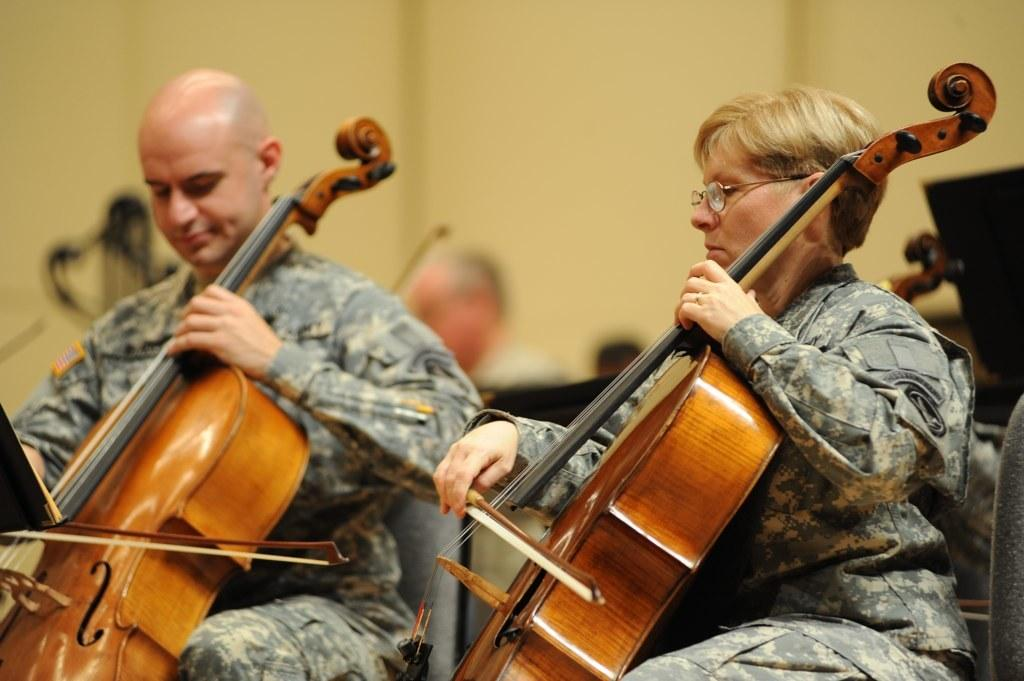What is the man in the image doing? The man is sitting and playing the violin. What is the woman in the image doing? The woman is also sitting and playing the violin. What can be seen in the background of the image? There is a wall in the background of the image. How many people are playing violins in the image? There are two people playing violins in the image. Can you describe the person sitting behind the two violin players? There is a person sitting behind the two people playing violin, but their actions are not visible in the image. Reasoning: Let'g: Let's think step by step in order to produce the conversation. We start by identifying the main subjects in the image, which are the two people playing violins. Then, we describe their actions and the presence of the wall in the background. We also mention the person sitting behind them, acknowledging that their actions are not visible in the image. Each question is designed to elicit a specific detail about the image that is known from the provided facts. Absurd Question/Answer: What type of trail can be seen in the image? There is no trail present in the image; it features two people playing violins and a person sitting behind them. How many spiders are crawling on the violins in the image? There are no spiders visible in the image; it features two people playing violins and a person sitting behind them. 